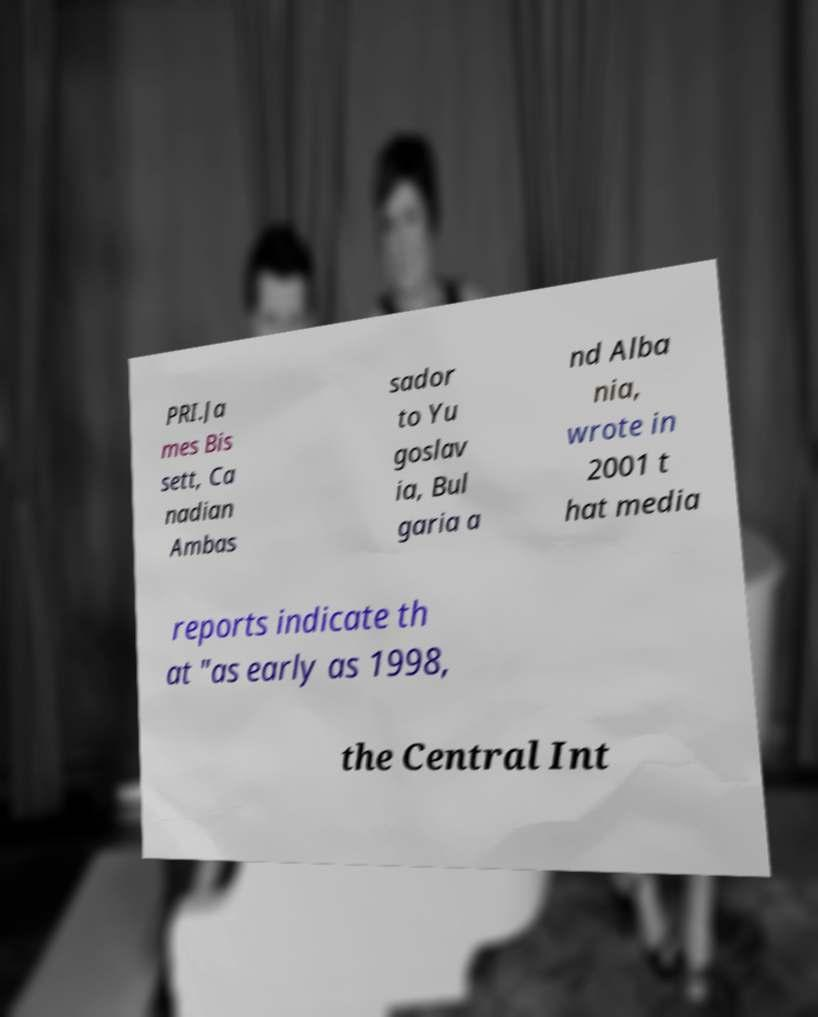Please read and relay the text visible in this image. What does it say? PRI.Ja mes Bis sett, Ca nadian Ambas sador to Yu goslav ia, Bul garia a nd Alba nia, wrote in 2001 t hat media reports indicate th at "as early as 1998, the Central Int 